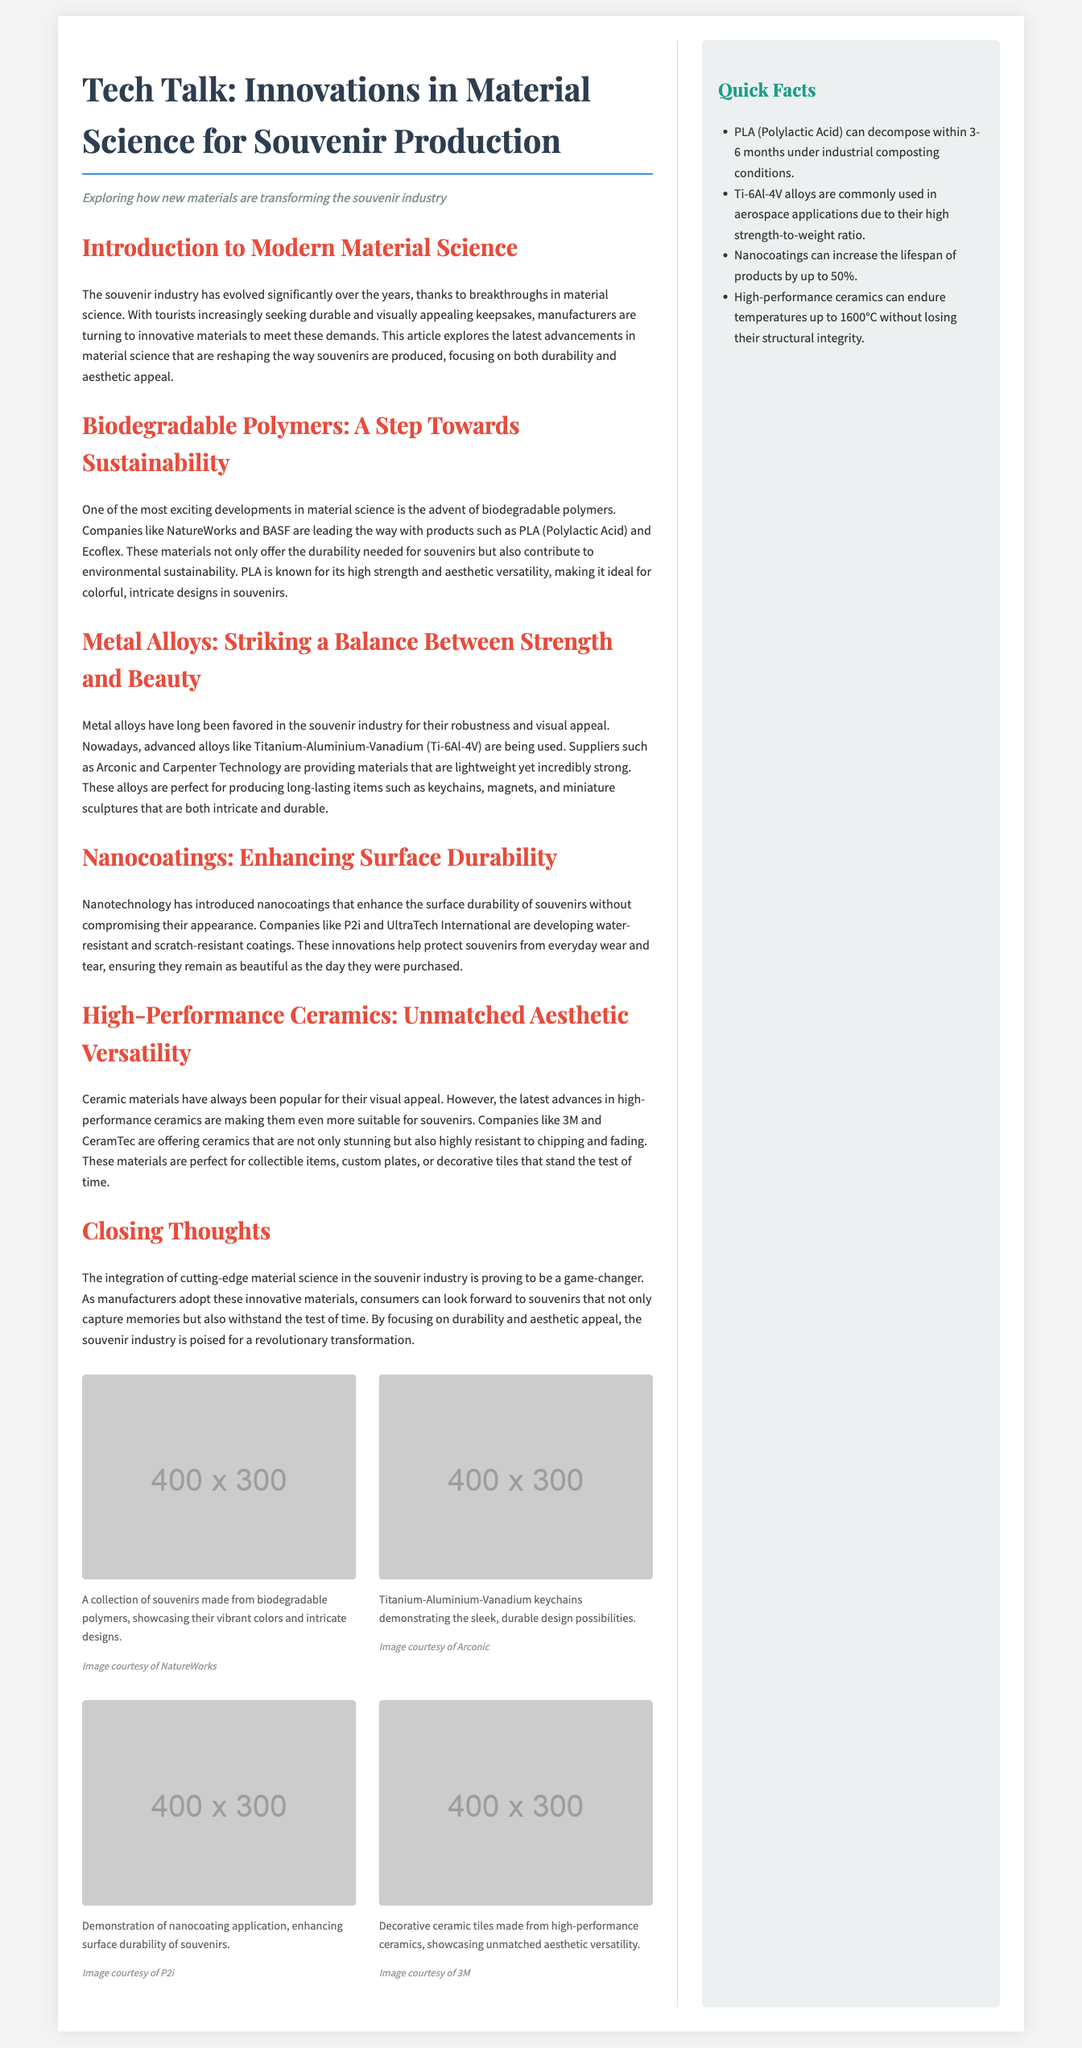What are the two main focuses in the souvenir industry according to the article? The article emphasizes that manufacturers are focusing on both durability and aesthetic appeal in the souvenir industry.
Answer: durability and aesthetic appeal Which company produces PLA? The document mentions NatureWorks as a company that leads in producing PLA (Polylactic Acid).
Answer: NatureWorks What alloy is mentioned in the context of strength and beauty? The article discusses Titanium-Aluminium-Vanadium (Ti-6Al-4V) as a favored alloy for its robust and visually appealing properties.
Answer: Ti-6Al-4V How much can nanocoatings increase the lifespan of products? The document states that nanocoatings can increase the lifespan of products by up to 50%.
Answer: 50% What is one type of ceramic technology mentioned? High-performance ceramics are discussed in the article as an advancement that enhances visual appeal and resistance.
Answer: High-performance ceramics What kind of materials does the souvenir industry increasingly utilize? Manufacturers are turning to innovative materials that offer durability and visual appeal according to the text.
Answer: innovative materials Who are the two companies noted for developing biodegradable polymers? The article identifies NatureWorks and BASF as companies leading in biodegradable polymer production.
Answer: NatureWorks and BASF 